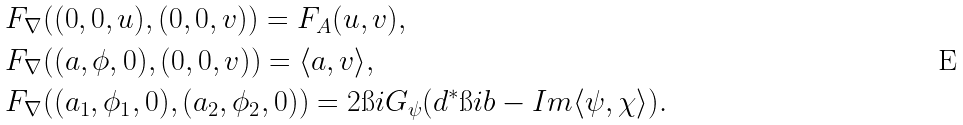<formula> <loc_0><loc_0><loc_500><loc_500>& F _ { \nabla } ( ( 0 , 0 , u ) , ( 0 , 0 , v ) ) = F _ { A } ( u , v ) , \\ & F _ { \nabla } ( ( a , \phi , 0 ) , ( 0 , 0 , v ) ) = \langle a , v \rangle , \\ & F _ { \nabla } ( ( a _ { 1 } , \phi _ { 1 } , 0 ) , ( a _ { 2 } , \phi _ { 2 } , 0 ) ) = 2 \i i G _ { \psi } ( d ^ { * } \i i b - I m \langle \psi , \chi \rangle ) .</formula> 